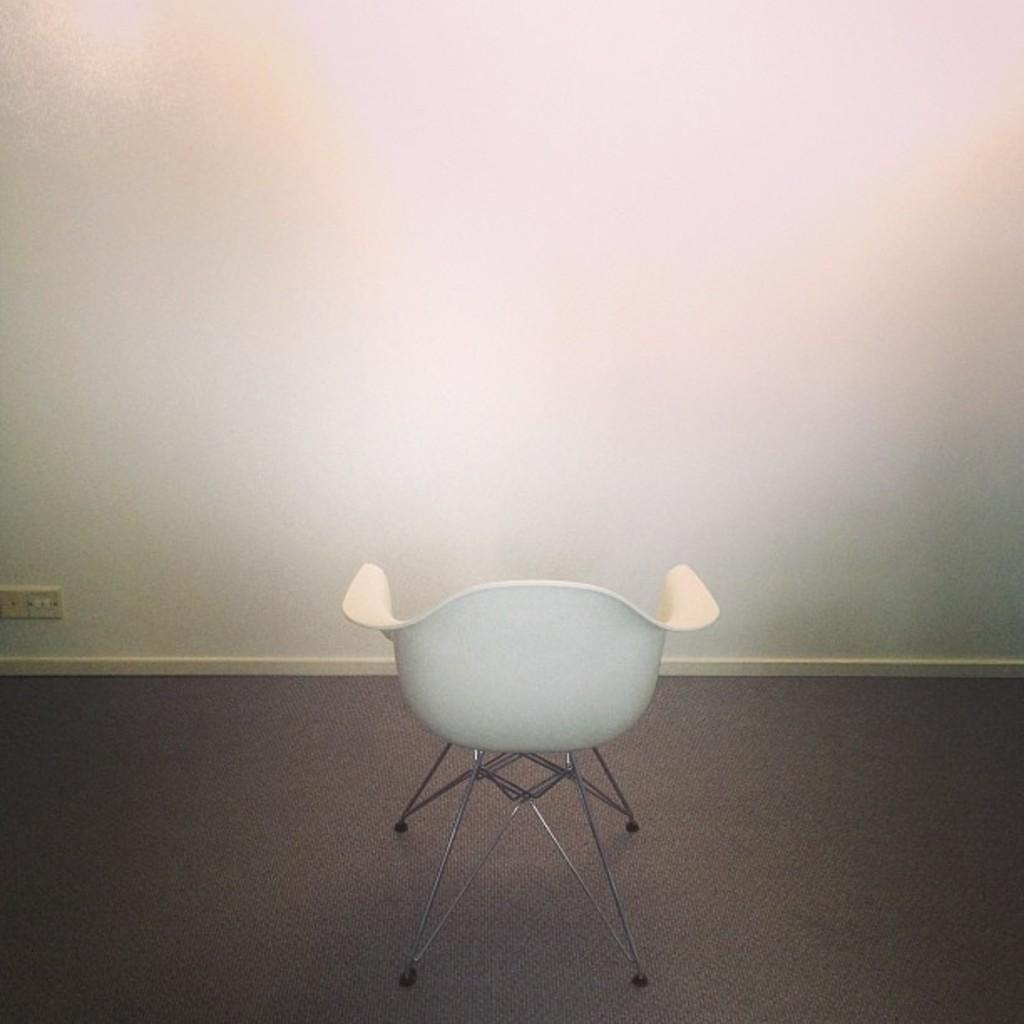What color is the chair in the image? The chair in the image is white. Where is the chair located in the image? The chair is on a surface. What color is the wall in the background of the image? The wall in the background of the image is white. What type of nerve is visible in the image? There is no nerve visible in the image; it features a white color chair on a surface with a white color wall in the background. 